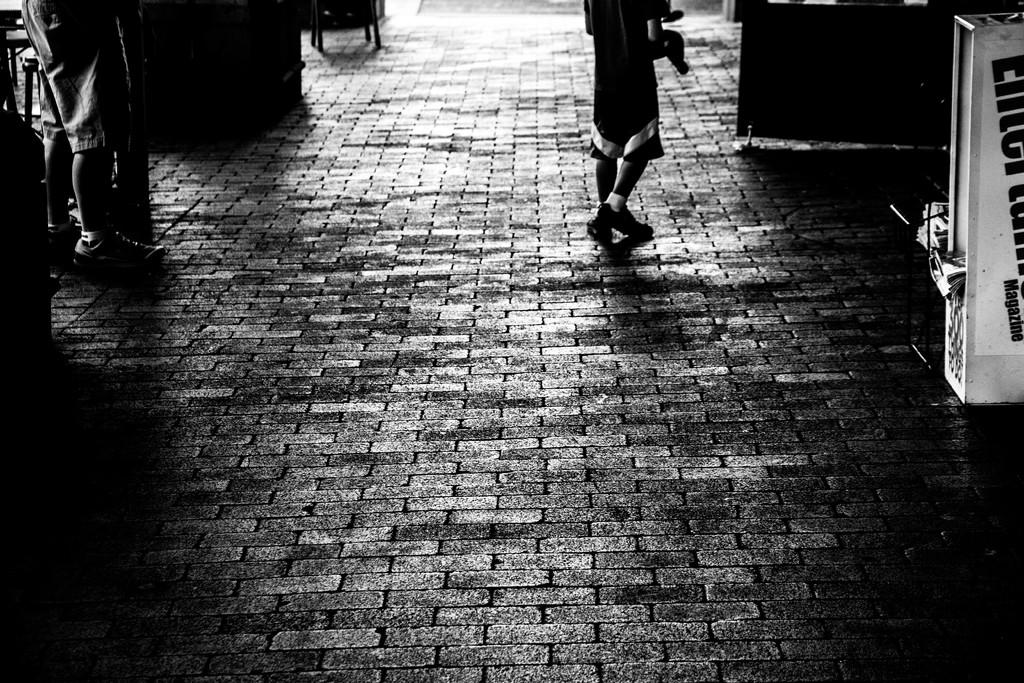What type of path is visible in the image? There is a walkway in the image. Where are the people located in the image? There are people standing on both the left and right sides of the image. What can be seen on the floor in the image? There are objects on the floor in the image. What type of health advice can be seen written on the walkway in the image? There is no health advice or writing visible on the walkway in the image. How many geese are present in the image? There are no geese present in the image. 